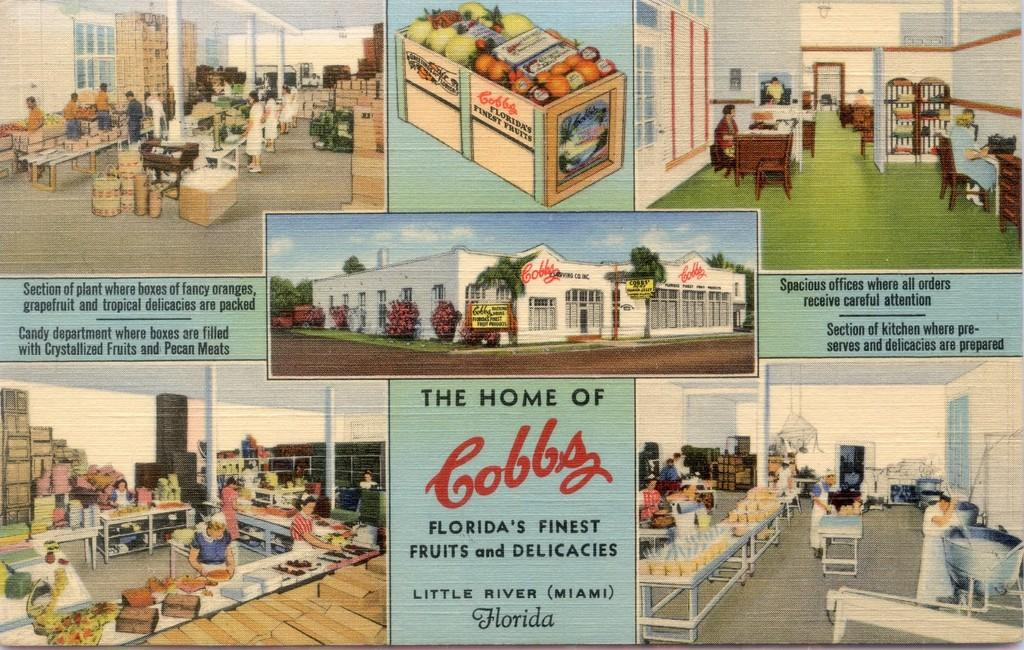What type of structure can be seen in the image? There is a building in the image. What natural elements are present in the image? There are trees in the image. What type of signage is visible in the image? Name boards are present in the image. What type of food items can be seen in the image? There is a box with fruits in the image. What type of furniture is visible in the image? Tables are visible in the image. What architectural feature is present in the building? Windows are present in the image. What else can be seen in the image? There are some objects in the image. What is visible in the background of the image? The sky is visible in the image, and clouds are present in the sky. Who or what is present in the image? There is a group of people in the image. Is there any text present in the image? Yes, there is some text in the image. How many rings are visible on the trees in the image? There are no rings visible on the trees in the image, as rings are not a feature of trees in this context. Where can the honey be found in the image? There is no honey present in the image. 